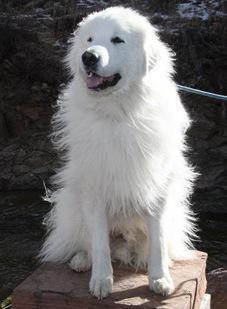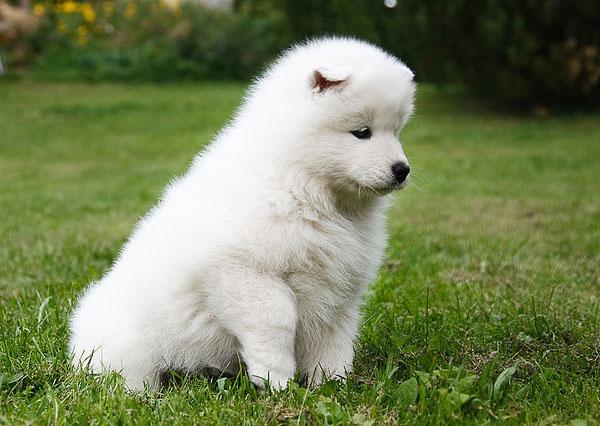The first image is the image on the left, the second image is the image on the right. Analyze the images presented: Is the assertion "Only one dog is contained in each image." valid? Answer yes or no. Yes. The first image is the image on the left, the second image is the image on the right. Given the left and right images, does the statement "Each image contains exactly one white dog, and each dog is in the same type of pose." hold true? Answer yes or no. Yes. 